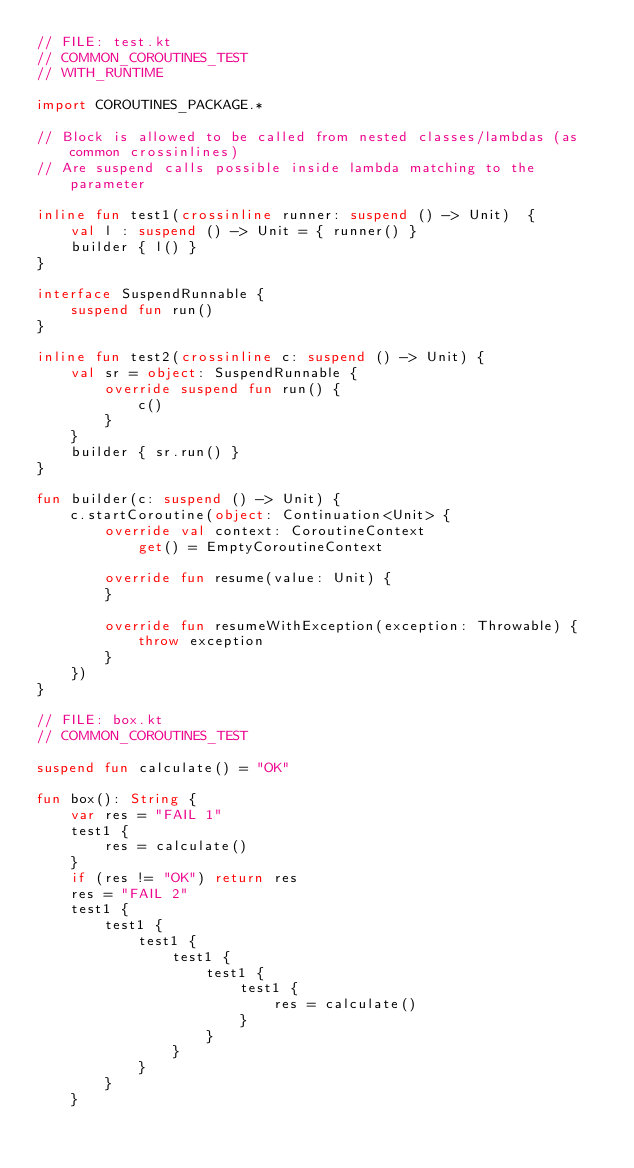Convert code to text. <code><loc_0><loc_0><loc_500><loc_500><_Kotlin_>// FILE: test.kt
// COMMON_COROUTINES_TEST
// WITH_RUNTIME

import COROUTINES_PACKAGE.*

// Block is allowed to be called from nested classes/lambdas (as common crossinlines)
// Are suspend calls possible inside lambda matching to the parameter

inline fun test1(crossinline runner: suspend () -> Unit)  {
    val l : suspend () -> Unit = { runner() }
    builder { l() }
}

interface SuspendRunnable {
    suspend fun run()
}

inline fun test2(crossinline c: suspend () -> Unit) {
    val sr = object: SuspendRunnable {
        override suspend fun run() {
            c()
        }
    }
    builder { sr.run() }
}

fun builder(c: suspend () -> Unit) {
    c.startCoroutine(object: Continuation<Unit> {
        override val context: CoroutineContext
            get() = EmptyCoroutineContext

        override fun resume(value: Unit) {
        }

        override fun resumeWithException(exception: Throwable) {
            throw exception
        }
    })
}

// FILE: box.kt
// COMMON_COROUTINES_TEST

suspend fun calculate() = "OK"

fun box(): String {
    var res = "FAIL 1"
    test1 {
        res = calculate()
    }
    if (res != "OK") return res
    res = "FAIL 2"
    test1 {
        test1 {
            test1 {
                test1 {
                    test1 {
                        test1 {
                            res = calculate()
                        }
                    }
                }
            }
        }
    }</code> 